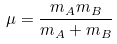<formula> <loc_0><loc_0><loc_500><loc_500>\mu = { \frac { m _ { A } m _ { B } } { m _ { A } + m _ { B } } }</formula> 